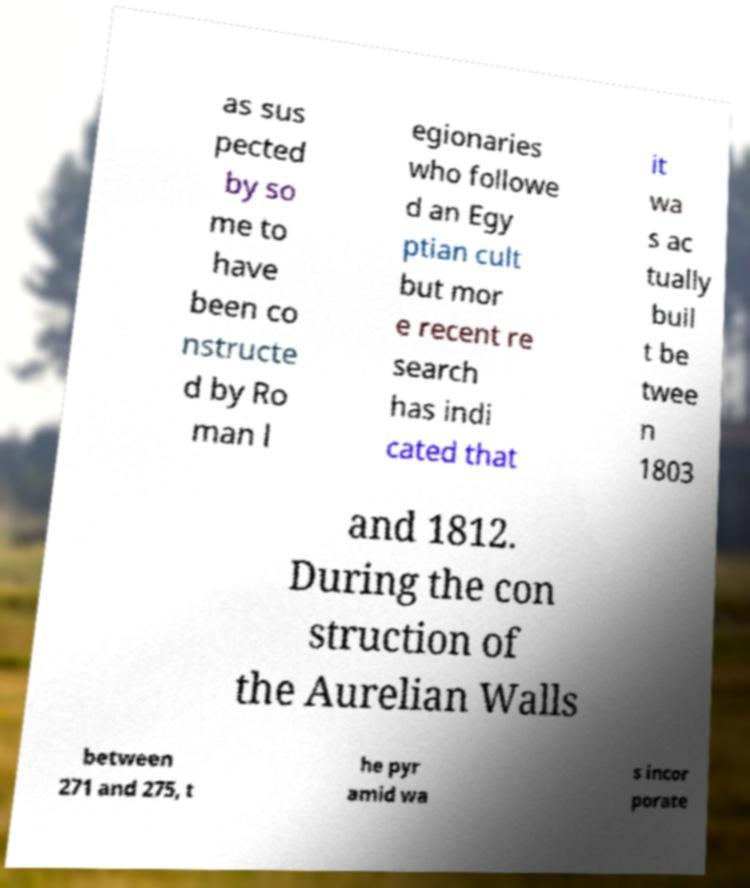Can you read and provide the text displayed in the image?This photo seems to have some interesting text. Can you extract and type it out for me? as sus pected by so me to have been co nstructe d by Ro man l egionaries who followe d an Egy ptian cult but mor e recent re search has indi cated that it wa s ac tually buil t be twee n 1803 and 1812. During the con struction of the Aurelian Walls between 271 and 275, t he pyr amid wa s incor porate 